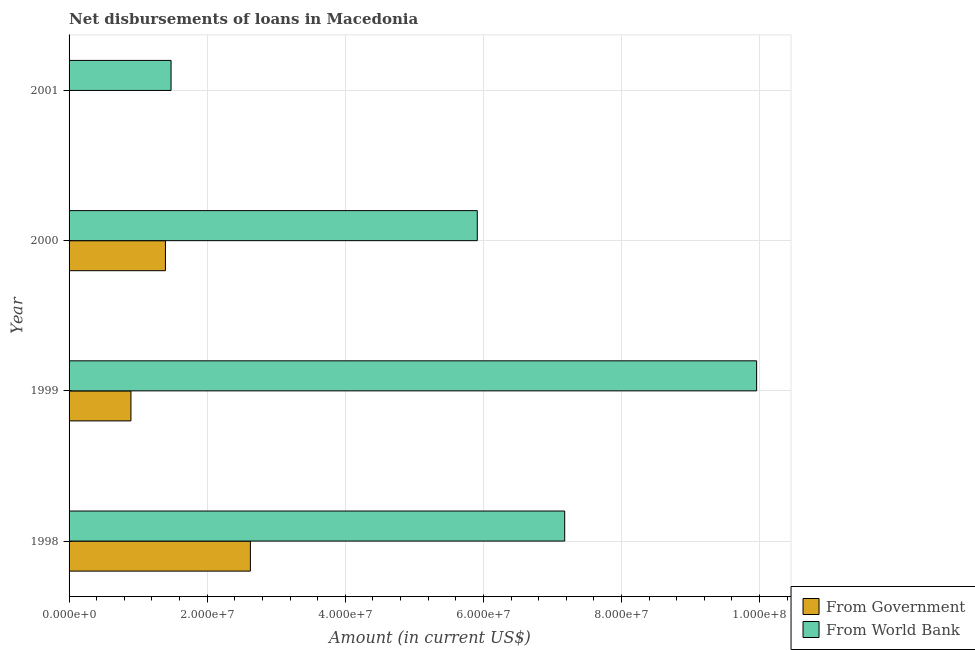How many bars are there on the 2nd tick from the bottom?
Keep it short and to the point. 2. What is the label of the 4th group of bars from the top?
Keep it short and to the point. 1998. In how many cases, is the number of bars for a given year not equal to the number of legend labels?
Provide a succinct answer. 1. What is the net disbursements of loan from world bank in 1999?
Make the answer very short. 9.96e+07. Across all years, what is the maximum net disbursements of loan from world bank?
Provide a short and direct response. 9.96e+07. Across all years, what is the minimum net disbursements of loan from world bank?
Your answer should be very brief. 1.48e+07. What is the total net disbursements of loan from government in the graph?
Offer a terse response. 4.92e+07. What is the difference between the net disbursements of loan from world bank in 1998 and that in 2000?
Your response must be concise. 1.27e+07. What is the difference between the net disbursements of loan from government in 1999 and the net disbursements of loan from world bank in 2001?
Provide a short and direct response. -5.81e+06. What is the average net disbursements of loan from government per year?
Provide a short and direct response. 1.23e+07. In the year 1999, what is the difference between the net disbursements of loan from government and net disbursements of loan from world bank?
Make the answer very short. -9.06e+07. What is the ratio of the net disbursements of loan from world bank in 1998 to that in 2000?
Provide a short and direct response. 1.21. Is the difference between the net disbursements of loan from government in 1998 and 1999 greater than the difference between the net disbursements of loan from world bank in 1998 and 1999?
Give a very brief answer. Yes. What is the difference between the highest and the second highest net disbursements of loan from government?
Give a very brief answer. 1.23e+07. What is the difference between the highest and the lowest net disbursements of loan from government?
Provide a succinct answer. 2.63e+07. In how many years, is the net disbursements of loan from world bank greater than the average net disbursements of loan from world bank taken over all years?
Your answer should be very brief. 2. Is the sum of the net disbursements of loan from government in 1999 and 2000 greater than the maximum net disbursements of loan from world bank across all years?
Provide a succinct answer. No. How many bars are there?
Offer a terse response. 7. Are all the bars in the graph horizontal?
Your answer should be very brief. Yes. How many years are there in the graph?
Make the answer very short. 4. Does the graph contain grids?
Offer a terse response. Yes. Where does the legend appear in the graph?
Your answer should be very brief. Bottom right. How many legend labels are there?
Provide a succinct answer. 2. How are the legend labels stacked?
Make the answer very short. Vertical. What is the title of the graph?
Give a very brief answer. Net disbursements of loans in Macedonia. Does "Forest land" appear as one of the legend labels in the graph?
Provide a succinct answer. No. What is the label or title of the Y-axis?
Ensure brevity in your answer.  Year. What is the Amount (in current US$) in From Government in 1998?
Provide a succinct answer. 2.63e+07. What is the Amount (in current US$) of From World Bank in 1998?
Provide a short and direct response. 7.18e+07. What is the Amount (in current US$) in From Government in 1999?
Your answer should be compact. 8.96e+06. What is the Amount (in current US$) in From World Bank in 1999?
Make the answer very short. 9.96e+07. What is the Amount (in current US$) in From Government in 2000?
Provide a short and direct response. 1.40e+07. What is the Amount (in current US$) in From World Bank in 2000?
Give a very brief answer. 5.91e+07. What is the Amount (in current US$) of From Government in 2001?
Your response must be concise. 0. What is the Amount (in current US$) in From World Bank in 2001?
Keep it short and to the point. 1.48e+07. Across all years, what is the maximum Amount (in current US$) in From Government?
Offer a terse response. 2.63e+07. Across all years, what is the maximum Amount (in current US$) of From World Bank?
Offer a very short reply. 9.96e+07. Across all years, what is the minimum Amount (in current US$) of From Government?
Provide a succinct answer. 0. Across all years, what is the minimum Amount (in current US$) in From World Bank?
Give a very brief answer. 1.48e+07. What is the total Amount (in current US$) of From Government in the graph?
Your answer should be compact. 4.92e+07. What is the total Amount (in current US$) in From World Bank in the graph?
Provide a short and direct response. 2.45e+08. What is the difference between the Amount (in current US$) in From Government in 1998 and that in 1999?
Your answer should be compact. 1.73e+07. What is the difference between the Amount (in current US$) in From World Bank in 1998 and that in 1999?
Your response must be concise. -2.78e+07. What is the difference between the Amount (in current US$) in From Government in 1998 and that in 2000?
Offer a terse response. 1.23e+07. What is the difference between the Amount (in current US$) in From World Bank in 1998 and that in 2000?
Your response must be concise. 1.27e+07. What is the difference between the Amount (in current US$) in From World Bank in 1998 and that in 2001?
Provide a short and direct response. 5.70e+07. What is the difference between the Amount (in current US$) in From Government in 1999 and that in 2000?
Provide a succinct answer. -5.00e+06. What is the difference between the Amount (in current US$) in From World Bank in 1999 and that in 2000?
Provide a short and direct response. 4.05e+07. What is the difference between the Amount (in current US$) of From World Bank in 1999 and that in 2001?
Keep it short and to the point. 8.48e+07. What is the difference between the Amount (in current US$) in From World Bank in 2000 and that in 2001?
Provide a short and direct response. 4.43e+07. What is the difference between the Amount (in current US$) of From Government in 1998 and the Amount (in current US$) of From World Bank in 1999?
Keep it short and to the point. -7.33e+07. What is the difference between the Amount (in current US$) of From Government in 1998 and the Amount (in current US$) of From World Bank in 2000?
Your answer should be very brief. -3.29e+07. What is the difference between the Amount (in current US$) of From Government in 1998 and the Amount (in current US$) of From World Bank in 2001?
Offer a terse response. 1.15e+07. What is the difference between the Amount (in current US$) of From Government in 1999 and the Amount (in current US$) of From World Bank in 2000?
Offer a terse response. -5.02e+07. What is the difference between the Amount (in current US$) in From Government in 1999 and the Amount (in current US$) in From World Bank in 2001?
Your answer should be compact. -5.81e+06. What is the difference between the Amount (in current US$) of From Government in 2000 and the Amount (in current US$) of From World Bank in 2001?
Your answer should be very brief. -8.15e+05. What is the average Amount (in current US$) of From Government per year?
Your answer should be compact. 1.23e+07. What is the average Amount (in current US$) in From World Bank per year?
Offer a very short reply. 6.13e+07. In the year 1998, what is the difference between the Amount (in current US$) in From Government and Amount (in current US$) in From World Bank?
Your answer should be very brief. -4.55e+07. In the year 1999, what is the difference between the Amount (in current US$) in From Government and Amount (in current US$) in From World Bank?
Provide a short and direct response. -9.06e+07. In the year 2000, what is the difference between the Amount (in current US$) of From Government and Amount (in current US$) of From World Bank?
Offer a terse response. -4.52e+07. What is the ratio of the Amount (in current US$) of From Government in 1998 to that in 1999?
Your answer should be very brief. 2.93. What is the ratio of the Amount (in current US$) in From World Bank in 1998 to that in 1999?
Provide a succinct answer. 0.72. What is the ratio of the Amount (in current US$) of From Government in 1998 to that in 2000?
Keep it short and to the point. 1.88. What is the ratio of the Amount (in current US$) of From World Bank in 1998 to that in 2000?
Your answer should be compact. 1.21. What is the ratio of the Amount (in current US$) of From World Bank in 1998 to that in 2001?
Your answer should be very brief. 4.86. What is the ratio of the Amount (in current US$) of From Government in 1999 to that in 2000?
Your answer should be compact. 0.64. What is the ratio of the Amount (in current US$) in From World Bank in 1999 to that in 2000?
Provide a short and direct response. 1.68. What is the ratio of the Amount (in current US$) in From World Bank in 1999 to that in 2001?
Provide a short and direct response. 6.74. What is the ratio of the Amount (in current US$) in From World Bank in 2000 to that in 2001?
Make the answer very short. 4. What is the difference between the highest and the second highest Amount (in current US$) in From Government?
Offer a very short reply. 1.23e+07. What is the difference between the highest and the second highest Amount (in current US$) in From World Bank?
Your answer should be very brief. 2.78e+07. What is the difference between the highest and the lowest Amount (in current US$) of From Government?
Ensure brevity in your answer.  2.63e+07. What is the difference between the highest and the lowest Amount (in current US$) of From World Bank?
Your answer should be compact. 8.48e+07. 